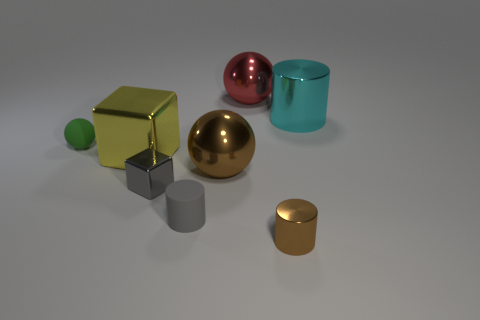What is the size of the cylinder that is the same color as the small metal block?
Provide a succinct answer. Small. Does the large cylinder have the same color as the small metal block?
Your answer should be compact. No. There is a shiny cylinder that is behind the brown ball; does it have the same color as the matte cylinder?
Give a very brief answer. No. Is there a large thing that has the same color as the tiny shiny cylinder?
Provide a succinct answer. Yes. What number of brown balls are behind the red metal ball?
Your answer should be very brief. 0. How many other things are the same size as the cyan metal thing?
Your answer should be very brief. 3. Are the sphere in front of the green thing and the gray object in front of the gray metal cube made of the same material?
Give a very brief answer. No. What is the color of the block that is the same size as the brown metal cylinder?
Offer a terse response. Gray. Are there any other things that are the same color as the big block?
Offer a very short reply. No. There is a shiny cylinder that is to the right of the shiny cylinder that is in front of the metallic sphere that is in front of the large cyan object; what size is it?
Ensure brevity in your answer.  Large. 